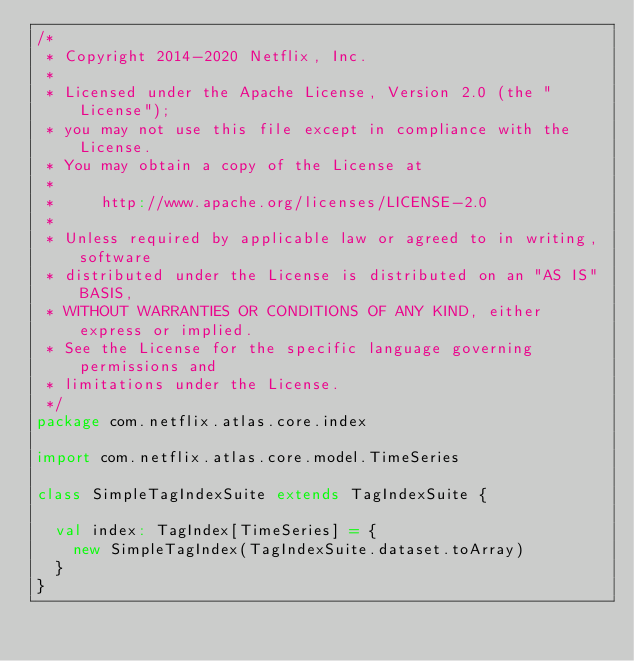Convert code to text. <code><loc_0><loc_0><loc_500><loc_500><_Scala_>/*
 * Copyright 2014-2020 Netflix, Inc.
 *
 * Licensed under the Apache License, Version 2.0 (the "License");
 * you may not use this file except in compliance with the License.
 * You may obtain a copy of the License at
 *
 *     http://www.apache.org/licenses/LICENSE-2.0
 *
 * Unless required by applicable law or agreed to in writing, software
 * distributed under the License is distributed on an "AS IS" BASIS,
 * WITHOUT WARRANTIES OR CONDITIONS OF ANY KIND, either express or implied.
 * See the License for the specific language governing permissions and
 * limitations under the License.
 */
package com.netflix.atlas.core.index

import com.netflix.atlas.core.model.TimeSeries

class SimpleTagIndexSuite extends TagIndexSuite {

  val index: TagIndex[TimeSeries] = {
    new SimpleTagIndex(TagIndexSuite.dataset.toArray)
  }
}
</code> 